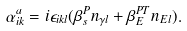<formula> <loc_0><loc_0><loc_500><loc_500>\alpha ^ { a } _ { i k } = i \epsilon _ { i k l } ( \beta ^ { P } _ { s } n _ { \gamma l } + \beta ^ { P T } _ { E } n _ { E l } ) .</formula> 